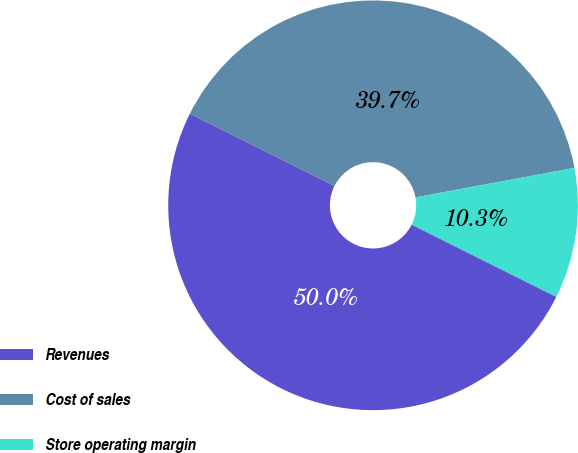Convert chart. <chart><loc_0><loc_0><loc_500><loc_500><pie_chart><fcel>Revenues<fcel>Cost of sales<fcel>Store operating margin<nl><fcel>50.0%<fcel>39.7%<fcel>10.3%<nl></chart> 